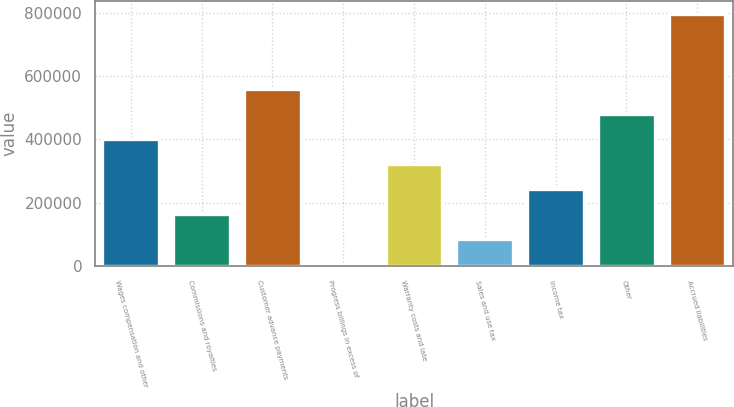Convert chart. <chart><loc_0><loc_0><loc_500><loc_500><bar_chart><fcel>Wages compensation and other<fcel>Commissions and royalties<fcel>Customer advance payments<fcel>Progress billings in excess of<fcel>Warranty costs and late<fcel>Sales and use tax<fcel>Income tax<fcel>Other<fcel>Accrued liabilities<nl><fcel>402424<fcel>165821<fcel>560160<fcel>8085<fcel>323557<fcel>86952.9<fcel>244689<fcel>481292<fcel>796764<nl></chart> 